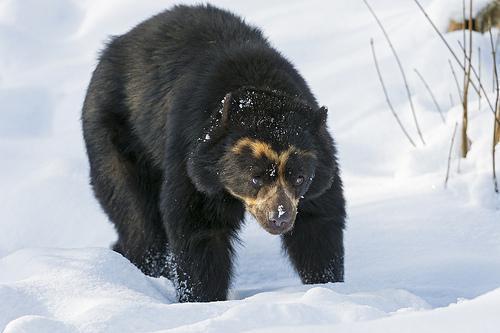How many bears are there?
Give a very brief answer. 1. How many of the bears legs are bent?
Give a very brief answer. 1. 